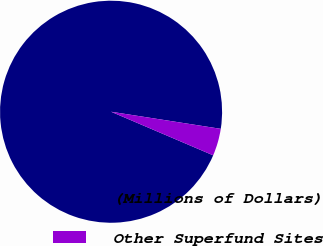Convert chart to OTSL. <chart><loc_0><loc_0><loc_500><loc_500><pie_chart><fcel>(Millions of Dollars)<fcel>Other Superfund Sites<nl><fcel>96.04%<fcel>3.96%<nl></chart> 